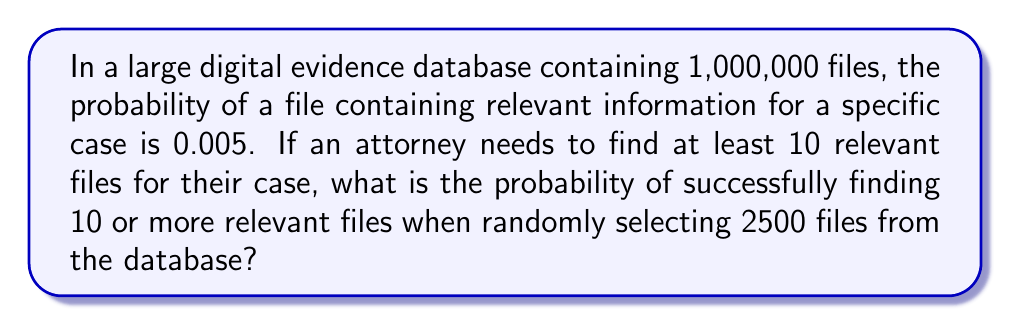Provide a solution to this math problem. To solve this problem, we can use the binomial distribution, as we're dealing with a fixed number of independent trials (selecting files) with two possible outcomes (relevant or not relevant).

Let $X$ be the random variable representing the number of relevant files found in 2500 selections.

1) We have:
   $n = 2500$ (number of files selected)
   $p = 0.005$ (probability of a file being relevant)
   $q = 1 - p = 0.995$ (probability of a file not being relevant)

2) We want to find $P(X \geq 10)$, which is equivalent to $1 - P(X < 10)$ or $1 - P(X \leq 9)$

3) The probability mass function of the binomial distribution is:

   $$P(X = k) = \binom{n}{k} p^k q^{n-k}$$

4) We need to calculate:

   $$P(X \geq 10) = 1 - \sum_{k=0}^9 \binom{2500}{k} (0.005)^k (0.995)^{2500-k}$$

5) This sum is computationally intensive, so we can use the normal approximation to the binomial distribution since $np = 2500 * 0.005 = 12.5 > 5$ and $nq = 2500 * 0.995 = 2487.5 > 5$

6) For the normal approximation:
   $\mu = np = 2500 * 0.005 = 12.5$
   $\sigma = \sqrt{npq} = \sqrt{2500 * 0.005 * 0.995} = 3.5$

7) We need to find $P(X \geq 9.5)$ due to the continuity correction:

   $$P(X \geq 10) \approx P(Z \geq \frac{9.5 - 12.5}{3.5}) = P(Z \geq -0.8571)$$

8) Using a standard normal table or calculator, we find:
   $P(Z \geq -0.8571) \approx 0.8043$

Therefore, the probability of finding 10 or more relevant files is approximately 0.8043 or 80.43%.
Answer: The probability of finding 10 or more relevant files when randomly selecting 2500 files from the database is approximately 0.8043 or 80.43%. 